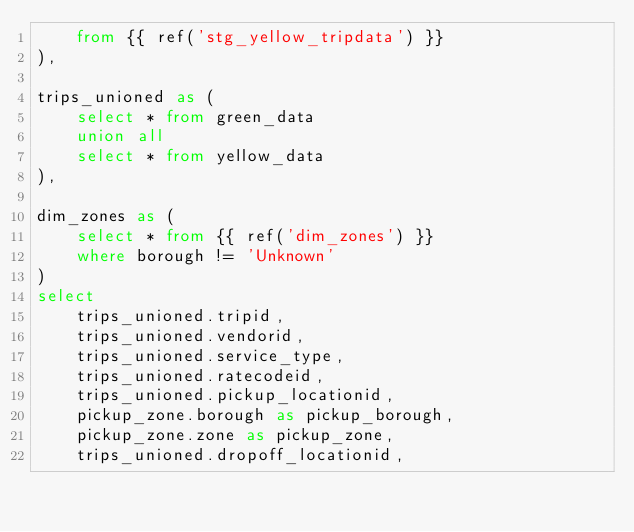<code> <loc_0><loc_0><loc_500><loc_500><_SQL_>    from {{ ref('stg_yellow_tripdata') }}
), 

trips_unioned as (
    select * from green_data
    union all
    select * from yellow_data
), 

dim_zones as (
    select * from {{ ref('dim_zones') }}
    where borough != 'Unknown'
)
select 
    trips_unioned.tripid, 
    trips_unioned.vendorid, 
    trips_unioned.service_type,
    trips_unioned.ratecodeid, 
    trips_unioned.pickup_locationid, 
    pickup_zone.borough as pickup_borough, 
    pickup_zone.zone as pickup_zone, 
    trips_unioned.dropoff_locationid,</code> 